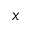Convert formula to latex. <formula><loc_0><loc_0><loc_500><loc_500>x</formula> 